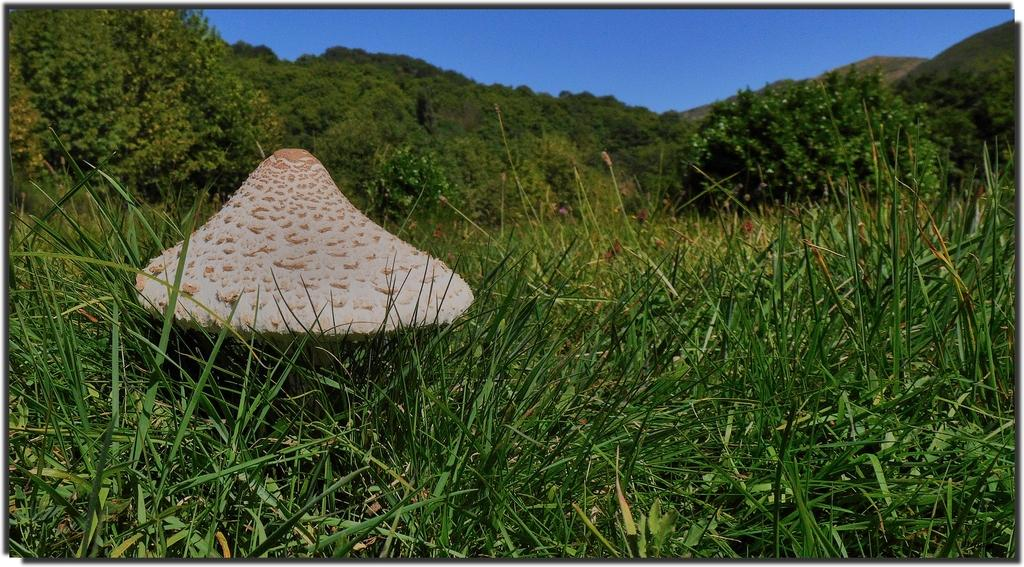What is the main subject of the image? There is a mushroom in the image. Where is the mushroom located? The mushroom is on the ground. What other natural elements can be seen in the image? There are plants and trees in the image. What can be seen in the background of the image? There are mountains and a clear sky in the background of the image. How many frogs are jumping around the mushroom in the image? There are no frogs present in the image. What type of war is depicted in the image? There is no war depicted in the image; it features a mushroom, plants, trees, mountains, and a clear sky. 